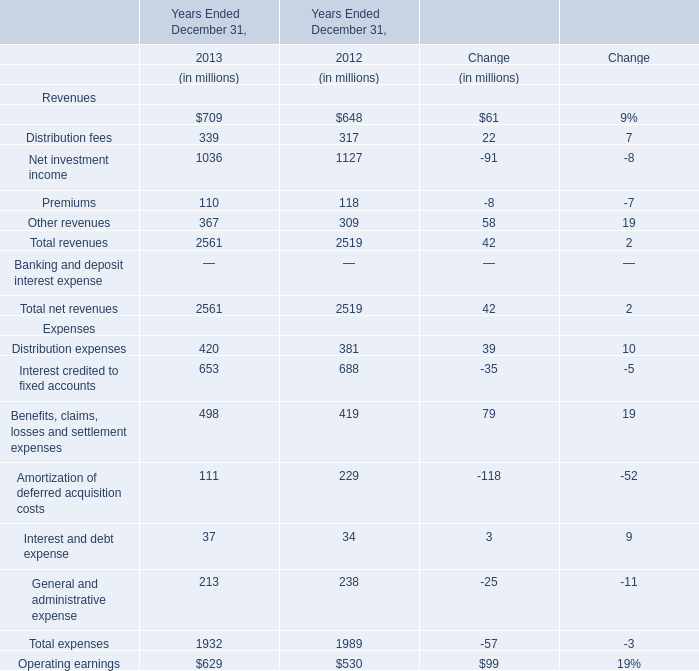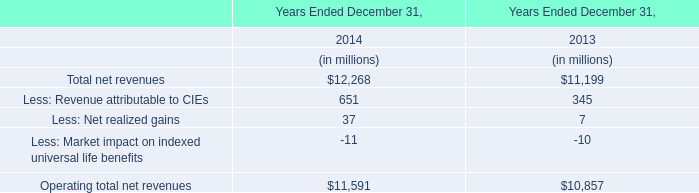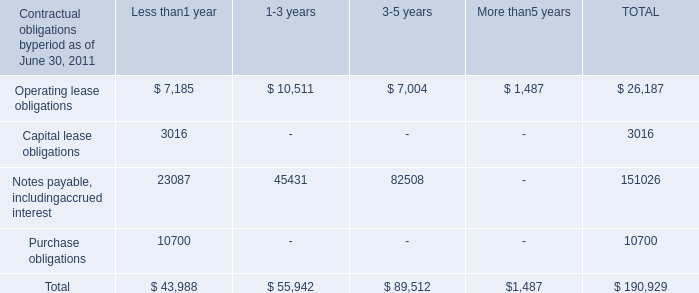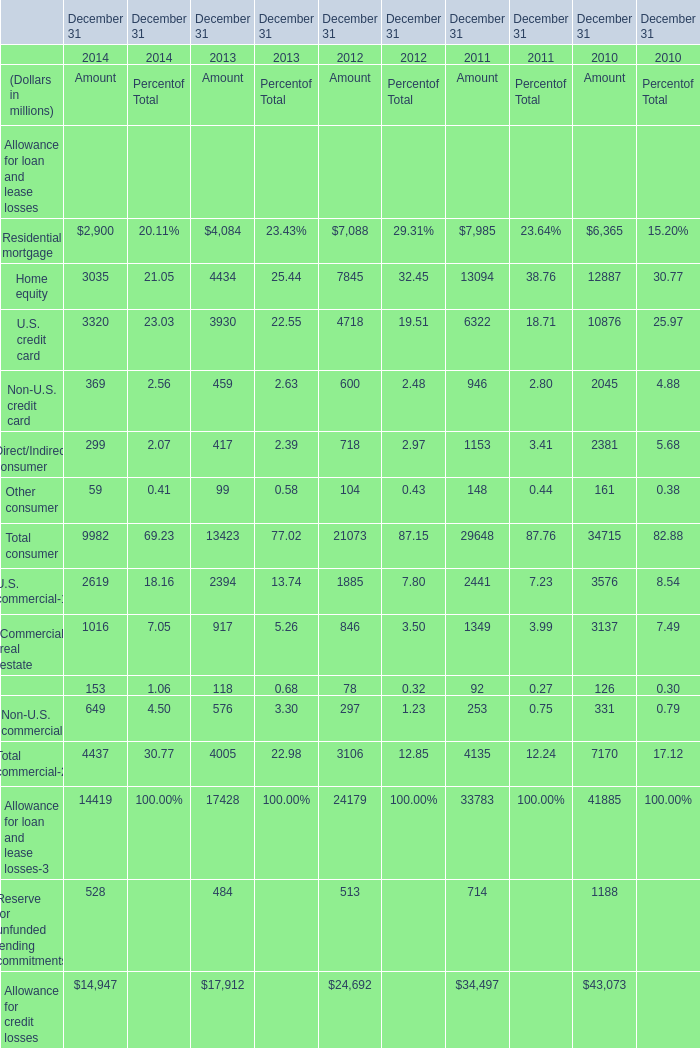What's the average of Operating lease obligations of TOTAL is, and Allowance for credit losses of December 31 2012 Amount ? 
Computations: ((26187.0 + 24692.0) / 2)
Answer: 25439.5. 